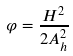<formula> <loc_0><loc_0><loc_500><loc_500>\varphi = \frac { H ^ { 2 } } { 2 A _ { h } ^ { 2 } }</formula> 